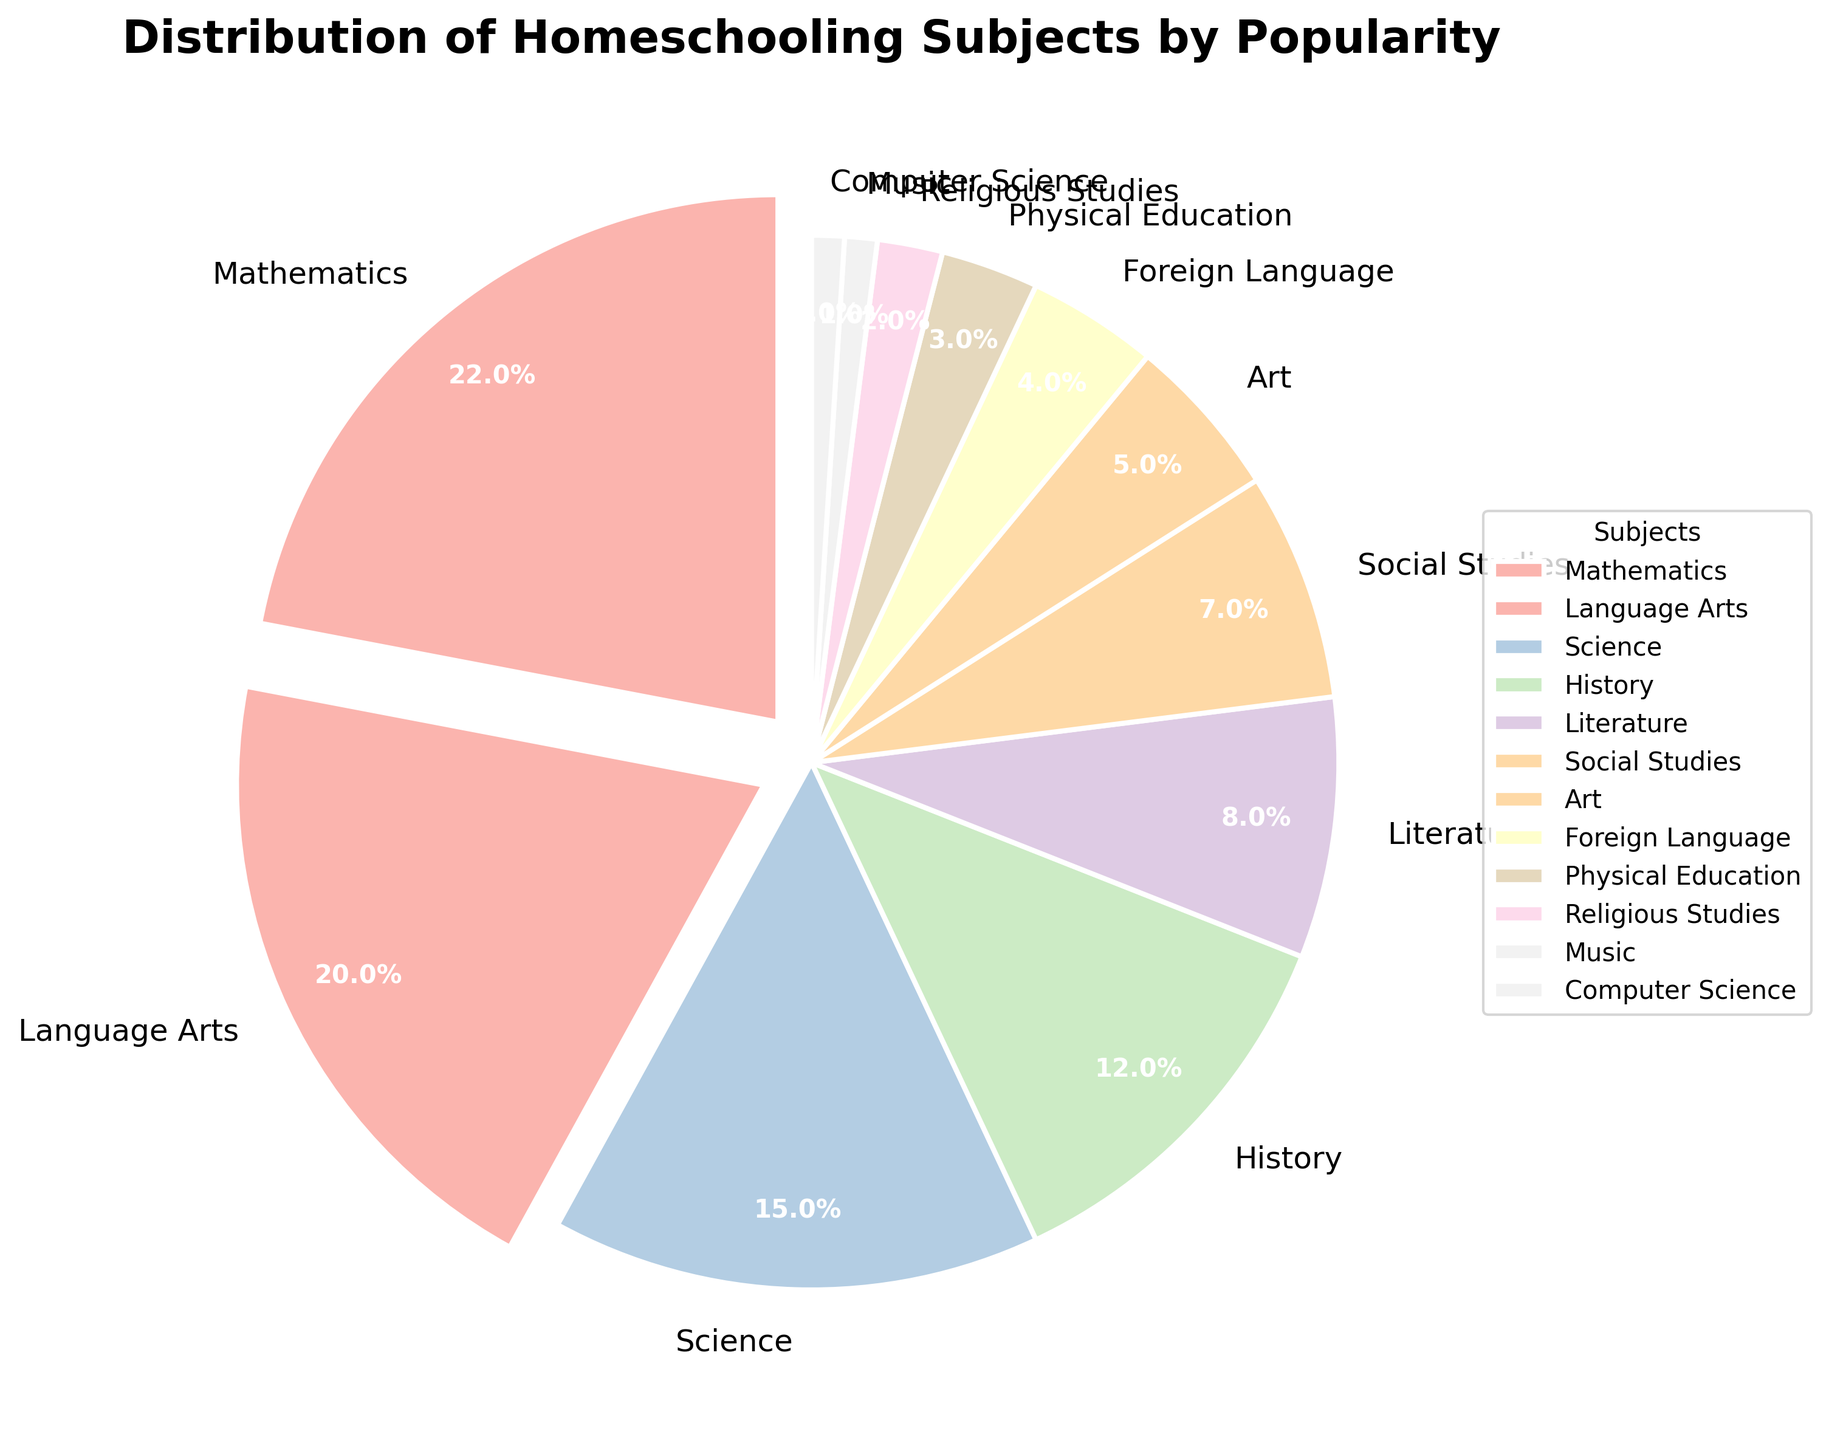Which subject is the most popular according to the pie chart? The most popular subject is the one with the highest percentage slice in the pie chart. Inspecting the chart, Mathematics has the largest slice.
Answer: Mathematics Which subject occupies the smallest percentage of the pie chart? By looking at the smallest slice of the pie chart, Music and Computer Science each occupy the smallest percentage at 1%.
Answer: Music and Computer Science What is the combined percentage of Science and History? To find the combined percentage, add the individual percentages of Science (15%) and History (12%). 15 + 12 = 27.
Answer: 27% Are there more families focusing on Art or Physical Education? By comparing the slices for Art (5%) and Physical Education (3%), Art is more focused on by families.
Answer: Art What is the percentage difference between Language Arts and Literature? Subtract the percentage for Literature (8%) from the percentage for Language Arts (20%). 20 - 8 = 12.
Answer: 12% What subjects are focused on by more than 15% of families? Subjects with slices greater than 15% are Mathematics (22%) and Language Arts (20%).
Answer: Mathematics and Language Arts How does the popularity of Social Studies compare to Foreign Language? By checking the percentages, Social Studies (7%) is more popular than Foreign Language (4%).
Answer: Social Studies is more popular Are the combined percentages of Foreign Language, Physical Education, and Religious Studies more than Literature? Add the percentages: Foreign Language (4%) + Physical Education (3%) + Religious Studies (2%) = 9%. Compare it with Literature (8%). 9% is more than 8%.
Answer: Yes Which subjects account for less than 5% of the overall distribution? Subjects with less than 5% are Foreign Language (4%), Physical Education (3%), Religious Studies (2%), Music (1%), and Computer Science (1%).
Answer: Foreign Language, Physical Education, Religious Studies, Music, Computer Science What is the combined percentage of all subjects with a percentage lower than Social Studies? Combine the percentages of Art, Foreign Language, Physical Education, Religious Studies, Music, and Computer Science: 5 + 4 + 3 + 2 + 1 + 1 = 16%.
Answer: 16% 